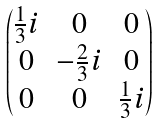Convert formula to latex. <formula><loc_0><loc_0><loc_500><loc_500>\begin{pmatrix} \frac { 1 } { 3 } i & 0 & 0 \\ 0 & - \frac { 2 } { 3 } i & 0 \\ 0 & 0 & \frac { 1 } { 3 } i \\ \end{pmatrix}</formula> 